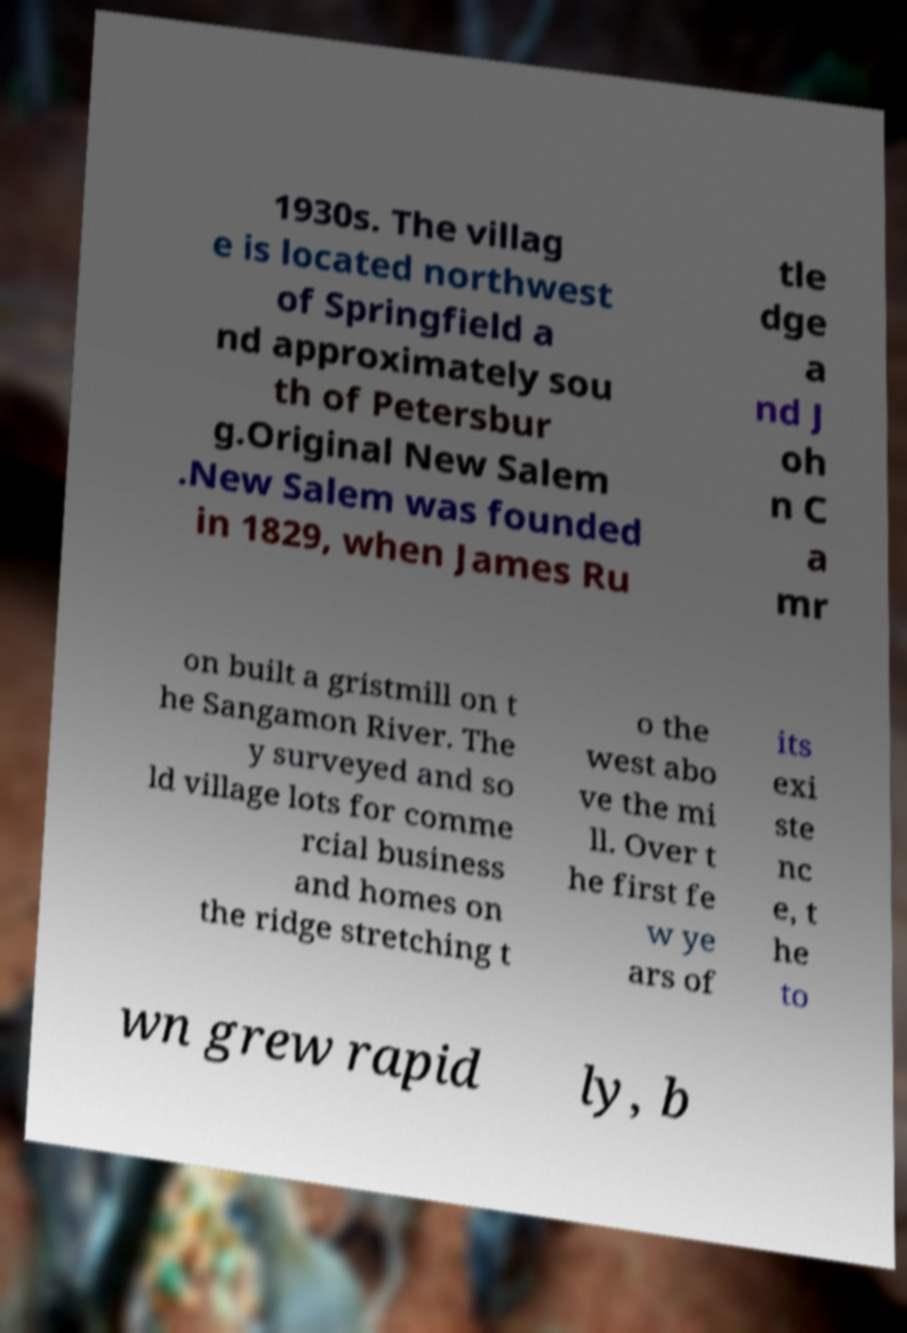Please identify and transcribe the text found in this image. 1930s. The villag e is located northwest of Springfield a nd approximately sou th of Petersbur g.Original New Salem .New Salem was founded in 1829, when James Ru tle dge a nd J oh n C a mr on built a gristmill on t he Sangamon River. The y surveyed and so ld village lots for comme rcial business and homes on the ridge stretching t o the west abo ve the mi ll. Over t he first fe w ye ars of its exi ste nc e, t he to wn grew rapid ly, b 